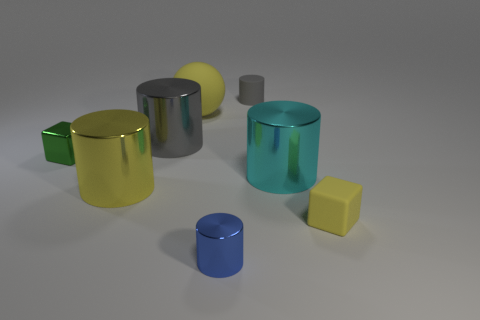Subtract all yellow cubes. How many gray cylinders are left? 2 Subtract 2 cylinders. How many cylinders are left? 3 Subtract all small shiny cylinders. How many cylinders are left? 4 Subtract all gray cylinders. How many cylinders are left? 3 Add 1 big gray things. How many objects exist? 9 Subtract all purple cylinders. Subtract all gray balls. How many cylinders are left? 5 Subtract all cylinders. How many objects are left? 3 Subtract all tiny yellow cubes. Subtract all large gray matte cylinders. How many objects are left? 7 Add 1 gray shiny cylinders. How many gray shiny cylinders are left? 2 Add 2 tiny green rubber cylinders. How many tiny green rubber cylinders exist? 2 